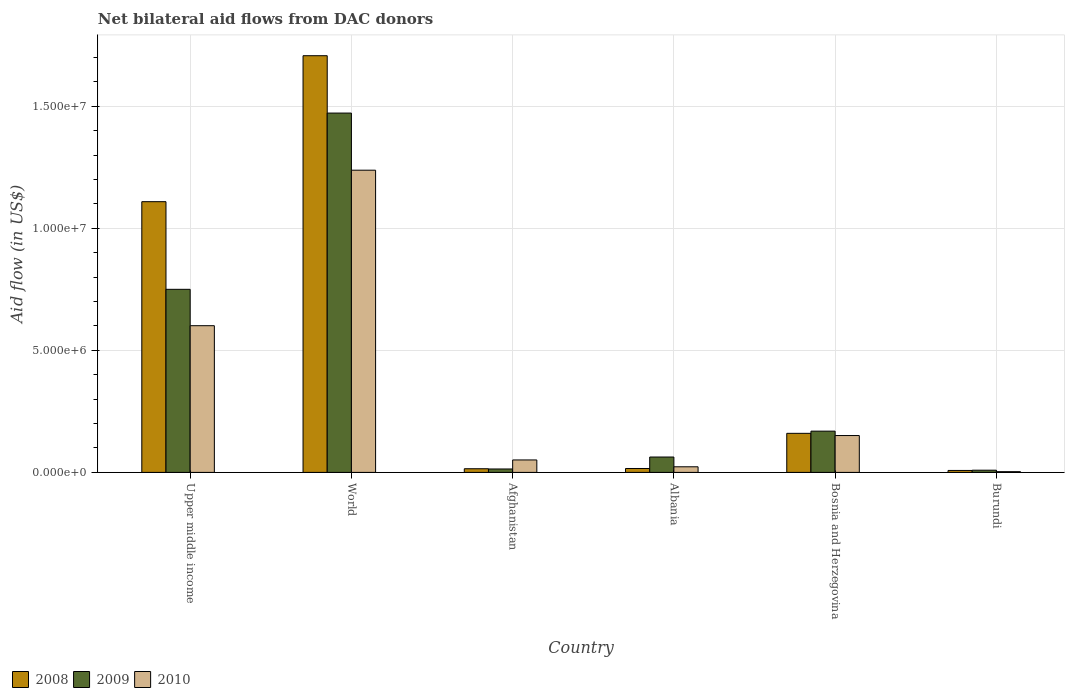How many different coloured bars are there?
Give a very brief answer. 3. Are the number of bars per tick equal to the number of legend labels?
Offer a very short reply. Yes. How many bars are there on the 4th tick from the left?
Ensure brevity in your answer.  3. How many bars are there on the 6th tick from the right?
Make the answer very short. 3. What is the label of the 5th group of bars from the left?
Your response must be concise. Bosnia and Herzegovina. What is the net bilateral aid flow in 2009 in Burundi?
Provide a succinct answer. 9.00e+04. Across all countries, what is the maximum net bilateral aid flow in 2008?
Offer a terse response. 1.71e+07. Across all countries, what is the minimum net bilateral aid flow in 2010?
Offer a terse response. 3.00e+04. In which country was the net bilateral aid flow in 2010 minimum?
Ensure brevity in your answer.  Burundi. What is the total net bilateral aid flow in 2010 in the graph?
Your response must be concise. 2.07e+07. What is the difference between the net bilateral aid flow in 2008 in Albania and that in World?
Keep it short and to the point. -1.69e+07. What is the difference between the net bilateral aid flow in 2009 in Albania and the net bilateral aid flow in 2010 in Upper middle income?
Give a very brief answer. -5.38e+06. What is the average net bilateral aid flow in 2008 per country?
Offer a terse response. 5.02e+06. What is the difference between the net bilateral aid flow of/in 2010 and net bilateral aid flow of/in 2009 in Albania?
Your response must be concise. -4.00e+05. In how many countries, is the net bilateral aid flow in 2010 greater than 8000000 US$?
Make the answer very short. 1. What is the ratio of the net bilateral aid flow in 2008 in Burundi to that in World?
Provide a short and direct response. 0. Is the net bilateral aid flow in 2008 in Afghanistan less than that in Burundi?
Your response must be concise. No. What is the difference between the highest and the second highest net bilateral aid flow in 2010?
Provide a short and direct response. 1.09e+07. What is the difference between the highest and the lowest net bilateral aid flow in 2010?
Offer a terse response. 1.24e+07. In how many countries, is the net bilateral aid flow in 2010 greater than the average net bilateral aid flow in 2010 taken over all countries?
Ensure brevity in your answer.  2. Is the sum of the net bilateral aid flow in 2009 in Afghanistan and Bosnia and Herzegovina greater than the maximum net bilateral aid flow in 2010 across all countries?
Offer a terse response. No. What does the 3rd bar from the right in Burundi represents?
Provide a short and direct response. 2008. Is it the case that in every country, the sum of the net bilateral aid flow in 2009 and net bilateral aid flow in 2008 is greater than the net bilateral aid flow in 2010?
Give a very brief answer. No. How many bars are there?
Your response must be concise. 18. Are all the bars in the graph horizontal?
Give a very brief answer. No. What is the difference between two consecutive major ticks on the Y-axis?
Offer a very short reply. 5.00e+06. Where does the legend appear in the graph?
Make the answer very short. Bottom left. What is the title of the graph?
Give a very brief answer. Net bilateral aid flows from DAC donors. What is the label or title of the X-axis?
Offer a very short reply. Country. What is the label or title of the Y-axis?
Your answer should be very brief. Aid flow (in US$). What is the Aid flow (in US$) of 2008 in Upper middle income?
Keep it short and to the point. 1.11e+07. What is the Aid flow (in US$) in 2009 in Upper middle income?
Your answer should be compact. 7.50e+06. What is the Aid flow (in US$) of 2010 in Upper middle income?
Your answer should be very brief. 6.01e+06. What is the Aid flow (in US$) of 2008 in World?
Your answer should be compact. 1.71e+07. What is the Aid flow (in US$) in 2009 in World?
Your answer should be compact. 1.47e+07. What is the Aid flow (in US$) of 2010 in World?
Your answer should be compact. 1.24e+07. What is the Aid flow (in US$) in 2010 in Afghanistan?
Keep it short and to the point. 5.10e+05. What is the Aid flow (in US$) in 2008 in Albania?
Provide a short and direct response. 1.60e+05. What is the Aid flow (in US$) of 2009 in Albania?
Keep it short and to the point. 6.30e+05. What is the Aid flow (in US$) of 2010 in Albania?
Offer a very short reply. 2.30e+05. What is the Aid flow (in US$) of 2008 in Bosnia and Herzegovina?
Keep it short and to the point. 1.60e+06. What is the Aid flow (in US$) of 2009 in Bosnia and Herzegovina?
Make the answer very short. 1.69e+06. What is the Aid flow (in US$) in 2010 in Bosnia and Herzegovina?
Offer a terse response. 1.51e+06. What is the Aid flow (in US$) in 2008 in Burundi?
Provide a succinct answer. 8.00e+04. Across all countries, what is the maximum Aid flow (in US$) in 2008?
Provide a short and direct response. 1.71e+07. Across all countries, what is the maximum Aid flow (in US$) in 2009?
Provide a short and direct response. 1.47e+07. Across all countries, what is the maximum Aid flow (in US$) of 2010?
Provide a short and direct response. 1.24e+07. Across all countries, what is the minimum Aid flow (in US$) of 2009?
Provide a succinct answer. 9.00e+04. Across all countries, what is the minimum Aid flow (in US$) of 2010?
Provide a short and direct response. 3.00e+04. What is the total Aid flow (in US$) of 2008 in the graph?
Ensure brevity in your answer.  3.02e+07. What is the total Aid flow (in US$) of 2009 in the graph?
Your answer should be very brief. 2.48e+07. What is the total Aid flow (in US$) in 2010 in the graph?
Provide a short and direct response. 2.07e+07. What is the difference between the Aid flow (in US$) in 2008 in Upper middle income and that in World?
Your answer should be compact. -5.98e+06. What is the difference between the Aid flow (in US$) in 2009 in Upper middle income and that in World?
Your answer should be very brief. -7.22e+06. What is the difference between the Aid flow (in US$) of 2010 in Upper middle income and that in World?
Offer a terse response. -6.37e+06. What is the difference between the Aid flow (in US$) of 2008 in Upper middle income and that in Afghanistan?
Offer a very short reply. 1.09e+07. What is the difference between the Aid flow (in US$) in 2009 in Upper middle income and that in Afghanistan?
Give a very brief answer. 7.36e+06. What is the difference between the Aid flow (in US$) of 2010 in Upper middle income and that in Afghanistan?
Provide a succinct answer. 5.50e+06. What is the difference between the Aid flow (in US$) of 2008 in Upper middle income and that in Albania?
Your response must be concise. 1.09e+07. What is the difference between the Aid flow (in US$) in 2009 in Upper middle income and that in Albania?
Make the answer very short. 6.87e+06. What is the difference between the Aid flow (in US$) of 2010 in Upper middle income and that in Albania?
Your answer should be compact. 5.78e+06. What is the difference between the Aid flow (in US$) of 2008 in Upper middle income and that in Bosnia and Herzegovina?
Ensure brevity in your answer.  9.49e+06. What is the difference between the Aid flow (in US$) in 2009 in Upper middle income and that in Bosnia and Herzegovina?
Offer a terse response. 5.81e+06. What is the difference between the Aid flow (in US$) in 2010 in Upper middle income and that in Bosnia and Herzegovina?
Offer a terse response. 4.50e+06. What is the difference between the Aid flow (in US$) in 2008 in Upper middle income and that in Burundi?
Offer a terse response. 1.10e+07. What is the difference between the Aid flow (in US$) in 2009 in Upper middle income and that in Burundi?
Make the answer very short. 7.41e+06. What is the difference between the Aid flow (in US$) in 2010 in Upper middle income and that in Burundi?
Provide a short and direct response. 5.98e+06. What is the difference between the Aid flow (in US$) in 2008 in World and that in Afghanistan?
Provide a succinct answer. 1.69e+07. What is the difference between the Aid flow (in US$) of 2009 in World and that in Afghanistan?
Ensure brevity in your answer.  1.46e+07. What is the difference between the Aid flow (in US$) in 2010 in World and that in Afghanistan?
Your response must be concise. 1.19e+07. What is the difference between the Aid flow (in US$) of 2008 in World and that in Albania?
Keep it short and to the point. 1.69e+07. What is the difference between the Aid flow (in US$) of 2009 in World and that in Albania?
Provide a succinct answer. 1.41e+07. What is the difference between the Aid flow (in US$) of 2010 in World and that in Albania?
Provide a short and direct response. 1.22e+07. What is the difference between the Aid flow (in US$) of 2008 in World and that in Bosnia and Herzegovina?
Offer a very short reply. 1.55e+07. What is the difference between the Aid flow (in US$) of 2009 in World and that in Bosnia and Herzegovina?
Make the answer very short. 1.30e+07. What is the difference between the Aid flow (in US$) in 2010 in World and that in Bosnia and Herzegovina?
Give a very brief answer. 1.09e+07. What is the difference between the Aid flow (in US$) in 2008 in World and that in Burundi?
Give a very brief answer. 1.70e+07. What is the difference between the Aid flow (in US$) of 2009 in World and that in Burundi?
Your answer should be very brief. 1.46e+07. What is the difference between the Aid flow (in US$) in 2010 in World and that in Burundi?
Give a very brief answer. 1.24e+07. What is the difference between the Aid flow (in US$) in 2009 in Afghanistan and that in Albania?
Your answer should be compact. -4.90e+05. What is the difference between the Aid flow (in US$) of 2008 in Afghanistan and that in Bosnia and Herzegovina?
Provide a succinct answer. -1.45e+06. What is the difference between the Aid flow (in US$) in 2009 in Afghanistan and that in Bosnia and Herzegovina?
Ensure brevity in your answer.  -1.55e+06. What is the difference between the Aid flow (in US$) in 2010 in Afghanistan and that in Bosnia and Herzegovina?
Make the answer very short. -1.00e+06. What is the difference between the Aid flow (in US$) in 2009 in Afghanistan and that in Burundi?
Offer a terse response. 5.00e+04. What is the difference between the Aid flow (in US$) in 2010 in Afghanistan and that in Burundi?
Your answer should be compact. 4.80e+05. What is the difference between the Aid flow (in US$) of 2008 in Albania and that in Bosnia and Herzegovina?
Your answer should be very brief. -1.44e+06. What is the difference between the Aid flow (in US$) of 2009 in Albania and that in Bosnia and Herzegovina?
Your answer should be compact. -1.06e+06. What is the difference between the Aid flow (in US$) in 2010 in Albania and that in Bosnia and Herzegovina?
Keep it short and to the point. -1.28e+06. What is the difference between the Aid flow (in US$) of 2008 in Albania and that in Burundi?
Offer a terse response. 8.00e+04. What is the difference between the Aid flow (in US$) of 2009 in Albania and that in Burundi?
Provide a short and direct response. 5.40e+05. What is the difference between the Aid flow (in US$) of 2008 in Bosnia and Herzegovina and that in Burundi?
Your answer should be very brief. 1.52e+06. What is the difference between the Aid flow (in US$) of 2009 in Bosnia and Herzegovina and that in Burundi?
Give a very brief answer. 1.60e+06. What is the difference between the Aid flow (in US$) of 2010 in Bosnia and Herzegovina and that in Burundi?
Your response must be concise. 1.48e+06. What is the difference between the Aid flow (in US$) of 2008 in Upper middle income and the Aid flow (in US$) of 2009 in World?
Your answer should be compact. -3.63e+06. What is the difference between the Aid flow (in US$) of 2008 in Upper middle income and the Aid flow (in US$) of 2010 in World?
Provide a short and direct response. -1.29e+06. What is the difference between the Aid flow (in US$) in 2009 in Upper middle income and the Aid flow (in US$) in 2010 in World?
Provide a succinct answer. -4.88e+06. What is the difference between the Aid flow (in US$) in 2008 in Upper middle income and the Aid flow (in US$) in 2009 in Afghanistan?
Keep it short and to the point. 1.10e+07. What is the difference between the Aid flow (in US$) of 2008 in Upper middle income and the Aid flow (in US$) of 2010 in Afghanistan?
Offer a very short reply. 1.06e+07. What is the difference between the Aid flow (in US$) in 2009 in Upper middle income and the Aid flow (in US$) in 2010 in Afghanistan?
Make the answer very short. 6.99e+06. What is the difference between the Aid flow (in US$) in 2008 in Upper middle income and the Aid flow (in US$) in 2009 in Albania?
Your answer should be compact. 1.05e+07. What is the difference between the Aid flow (in US$) in 2008 in Upper middle income and the Aid flow (in US$) in 2010 in Albania?
Keep it short and to the point. 1.09e+07. What is the difference between the Aid flow (in US$) in 2009 in Upper middle income and the Aid flow (in US$) in 2010 in Albania?
Ensure brevity in your answer.  7.27e+06. What is the difference between the Aid flow (in US$) of 2008 in Upper middle income and the Aid flow (in US$) of 2009 in Bosnia and Herzegovina?
Your response must be concise. 9.40e+06. What is the difference between the Aid flow (in US$) in 2008 in Upper middle income and the Aid flow (in US$) in 2010 in Bosnia and Herzegovina?
Offer a terse response. 9.58e+06. What is the difference between the Aid flow (in US$) of 2009 in Upper middle income and the Aid flow (in US$) of 2010 in Bosnia and Herzegovina?
Provide a short and direct response. 5.99e+06. What is the difference between the Aid flow (in US$) in 2008 in Upper middle income and the Aid flow (in US$) in 2009 in Burundi?
Offer a very short reply. 1.10e+07. What is the difference between the Aid flow (in US$) of 2008 in Upper middle income and the Aid flow (in US$) of 2010 in Burundi?
Your answer should be very brief. 1.11e+07. What is the difference between the Aid flow (in US$) in 2009 in Upper middle income and the Aid flow (in US$) in 2010 in Burundi?
Provide a succinct answer. 7.47e+06. What is the difference between the Aid flow (in US$) in 2008 in World and the Aid flow (in US$) in 2009 in Afghanistan?
Provide a short and direct response. 1.69e+07. What is the difference between the Aid flow (in US$) of 2008 in World and the Aid flow (in US$) of 2010 in Afghanistan?
Ensure brevity in your answer.  1.66e+07. What is the difference between the Aid flow (in US$) of 2009 in World and the Aid flow (in US$) of 2010 in Afghanistan?
Offer a terse response. 1.42e+07. What is the difference between the Aid flow (in US$) of 2008 in World and the Aid flow (in US$) of 2009 in Albania?
Give a very brief answer. 1.64e+07. What is the difference between the Aid flow (in US$) of 2008 in World and the Aid flow (in US$) of 2010 in Albania?
Ensure brevity in your answer.  1.68e+07. What is the difference between the Aid flow (in US$) of 2009 in World and the Aid flow (in US$) of 2010 in Albania?
Your answer should be very brief. 1.45e+07. What is the difference between the Aid flow (in US$) of 2008 in World and the Aid flow (in US$) of 2009 in Bosnia and Herzegovina?
Your response must be concise. 1.54e+07. What is the difference between the Aid flow (in US$) in 2008 in World and the Aid flow (in US$) in 2010 in Bosnia and Herzegovina?
Make the answer very short. 1.56e+07. What is the difference between the Aid flow (in US$) in 2009 in World and the Aid flow (in US$) in 2010 in Bosnia and Herzegovina?
Offer a terse response. 1.32e+07. What is the difference between the Aid flow (in US$) in 2008 in World and the Aid flow (in US$) in 2009 in Burundi?
Keep it short and to the point. 1.70e+07. What is the difference between the Aid flow (in US$) of 2008 in World and the Aid flow (in US$) of 2010 in Burundi?
Offer a very short reply. 1.70e+07. What is the difference between the Aid flow (in US$) of 2009 in World and the Aid flow (in US$) of 2010 in Burundi?
Provide a succinct answer. 1.47e+07. What is the difference between the Aid flow (in US$) of 2008 in Afghanistan and the Aid flow (in US$) of 2009 in Albania?
Provide a short and direct response. -4.80e+05. What is the difference between the Aid flow (in US$) of 2009 in Afghanistan and the Aid flow (in US$) of 2010 in Albania?
Offer a terse response. -9.00e+04. What is the difference between the Aid flow (in US$) in 2008 in Afghanistan and the Aid flow (in US$) in 2009 in Bosnia and Herzegovina?
Offer a terse response. -1.54e+06. What is the difference between the Aid flow (in US$) in 2008 in Afghanistan and the Aid flow (in US$) in 2010 in Bosnia and Herzegovina?
Provide a succinct answer. -1.36e+06. What is the difference between the Aid flow (in US$) of 2009 in Afghanistan and the Aid flow (in US$) of 2010 in Bosnia and Herzegovina?
Give a very brief answer. -1.37e+06. What is the difference between the Aid flow (in US$) of 2009 in Afghanistan and the Aid flow (in US$) of 2010 in Burundi?
Keep it short and to the point. 1.10e+05. What is the difference between the Aid flow (in US$) in 2008 in Albania and the Aid flow (in US$) in 2009 in Bosnia and Herzegovina?
Offer a terse response. -1.53e+06. What is the difference between the Aid flow (in US$) in 2008 in Albania and the Aid flow (in US$) in 2010 in Bosnia and Herzegovina?
Provide a succinct answer. -1.35e+06. What is the difference between the Aid flow (in US$) of 2009 in Albania and the Aid flow (in US$) of 2010 in Bosnia and Herzegovina?
Make the answer very short. -8.80e+05. What is the difference between the Aid flow (in US$) in 2008 in Albania and the Aid flow (in US$) in 2010 in Burundi?
Make the answer very short. 1.30e+05. What is the difference between the Aid flow (in US$) of 2009 in Albania and the Aid flow (in US$) of 2010 in Burundi?
Ensure brevity in your answer.  6.00e+05. What is the difference between the Aid flow (in US$) in 2008 in Bosnia and Herzegovina and the Aid flow (in US$) in 2009 in Burundi?
Make the answer very short. 1.51e+06. What is the difference between the Aid flow (in US$) of 2008 in Bosnia and Herzegovina and the Aid flow (in US$) of 2010 in Burundi?
Your response must be concise. 1.57e+06. What is the difference between the Aid flow (in US$) of 2009 in Bosnia and Herzegovina and the Aid flow (in US$) of 2010 in Burundi?
Offer a terse response. 1.66e+06. What is the average Aid flow (in US$) in 2008 per country?
Your answer should be very brief. 5.02e+06. What is the average Aid flow (in US$) of 2009 per country?
Offer a terse response. 4.13e+06. What is the average Aid flow (in US$) of 2010 per country?
Ensure brevity in your answer.  3.44e+06. What is the difference between the Aid flow (in US$) in 2008 and Aid flow (in US$) in 2009 in Upper middle income?
Provide a short and direct response. 3.59e+06. What is the difference between the Aid flow (in US$) in 2008 and Aid flow (in US$) in 2010 in Upper middle income?
Your answer should be compact. 5.08e+06. What is the difference between the Aid flow (in US$) of 2009 and Aid flow (in US$) of 2010 in Upper middle income?
Offer a terse response. 1.49e+06. What is the difference between the Aid flow (in US$) in 2008 and Aid flow (in US$) in 2009 in World?
Provide a succinct answer. 2.35e+06. What is the difference between the Aid flow (in US$) in 2008 and Aid flow (in US$) in 2010 in World?
Provide a succinct answer. 4.69e+06. What is the difference between the Aid flow (in US$) of 2009 and Aid flow (in US$) of 2010 in World?
Offer a terse response. 2.34e+06. What is the difference between the Aid flow (in US$) in 2008 and Aid flow (in US$) in 2010 in Afghanistan?
Ensure brevity in your answer.  -3.60e+05. What is the difference between the Aid flow (in US$) in 2009 and Aid flow (in US$) in 2010 in Afghanistan?
Provide a succinct answer. -3.70e+05. What is the difference between the Aid flow (in US$) of 2008 and Aid flow (in US$) of 2009 in Albania?
Ensure brevity in your answer.  -4.70e+05. What is the difference between the Aid flow (in US$) of 2008 and Aid flow (in US$) of 2009 in Bosnia and Herzegovina?
Give a very brief answer. -9.00e+04. What is the difference between the Aid flow (in US$) of 2009 and Aid flow (in US$) of 2010 in Bosnia and Herzegovina?
Your answer should be very brief. 1.80e+05. What is the difference between the Aid flow (in US$) in 2009 and Aid flow (in US$) in 2010 in Burundi?
Your response must be concise. 6.00e+04. What is the ratio of the Aid flow (in US$) in 2008 in Upper middle income to that in World?
Offer a terse response. 0.65. What is the ratio of the Aid flow (in US$) in 2009 in Upper middle income to that in World?
Your response must be concise. 0.51. What is the ratio of the Aid flow (in US$) in 2010 in Upper middle income to that in World?
Make the answer very short. 0.49. What is the ratio of the Aid flow (in US$) of 2008 in Upper middle income to that in Afghanistan?
Keep it short and to the point. 73.93. What is the ratio of the Aid flow (in US$) in 2009 in Upper middle income to that in Afghanistan?
Your answer should be very brief. 53.57. What is the ratio of the Aid flow (in US$) of 2010 in Upper middle income to that in Afghanistan?
Your response must be concise. 11.78. What is the ratio of the Aid flow (in US$) in 2008 in Upper middle income to that in Albania?
Your answer should be very brief. 69.31. What is the ratio of the Aid flow (in US$) in 2009 in Upper middle income to that in Albania?
Offer a very short reply. 11.9. What is the ratio of the Aid flow (in US$) of 2010 in Upper middle income to that in Albania?
Your answer should be compact. 26.13. What is the ratio of the Aid flow (in US$) of 2008 in Upper middle income to that in Bosnia and Herzegovina?
Offer a terse response. 6.93. What is the ratio of the Aid flow (in US$) of 2009 in Upper middle income to that in Bosnia and Herzegovina?
Your answer should be compact. 4.44. What is the ratio of the Aid flow (in US$) of 2010 in Upper middle income to that in Bosnia and Herzegovina?
Give a very brief answer. 3.98. What is the ratio of the Aid flow (in US$) of 2008 in Upper middle income to that in Burundi?
Your answer should be compact. 138.62. What is the ratio of the Aid flow (in US$) of 2009 in Upper middle income to that in Burundi?
Ensure brevity in your answer.  83.33. What is the ratio of the Aid flow (in US$) of 2010 in Upper middle income to that in Burundi?
Keep it short and to the point. 200.33. What is the ratio of the Aid flow (in US$) in 2008 in World to that in Afghanistan?
Provide a succinct answer. 113.8. What is the ratio of the Aid flow (in US$) in 2009 in World to that in Afghanistan?
Your answer should be compact. 105.14. What is the ratio of the Aid flow (in US$) of 2010 in World to that in Afghanistan?
Your answer should be compact. 24.27. What is the ratio of the Aid flow (in US$) in 2008 in World to that in Albania?
Provide a succinct answer. 106.69. What is the ratio of the Aid flow (in US$) of 2009 in World to that in Albania?
Ensure brevity in your answer.  23.37. What is the ratio of the Aid flow (in US$) of 2010 in World to that in Albania?
Your answer should be very brief. 53.83. What is the ratio of the Aid flow (in US$) of 2008 in World to that in Bosnia and Herzegovina?
Provide a short and direct response. 10.67. What is the ratio of the Aid flow (in US$) in 2009 in World to that in Bosnia and Herzegovina?
Keep it short and to the point. 8.71. What is the ratio of the Aid flow (in US$) in 2010 in World to that in Bosnia and Herzegovina?
Make the answer very short. 8.2. What is the ratio of the Aid flow (in US$) in 2008 in World to that in Burundi?
Offer a terse response. 213.38. What is the ratio of the Aid flow (in US$) in 2009 in World to that in Burundi?
Provide a succinct answer. 163.56. What is the ratio of the Aid flow (in US$) in 2010 in World to that in Burundi?
Make the answer very short. 412.67. What is the ratio of the Aid flow (in US$) in 2009 in Afghanistan to that in Albania?
Your answer should be compact. 0.22. What is the ratio of the Aid flow (in US$) in 2010 in Afghanistan to that in Albania?
Offer a terse response. 2.22. What is the ratio of the Aid flow (in US$) in 2008 in Afghanistan to that in Bosnia and Herzegovina?
Make the answer very short. 0.09. What is the ratio of the Aid flow (in US$) of 2009 in Afghanistan to that in Bosnia and Herzegovina?
Your answer should be very brief. 0.08. What is the ratio of the Aid flow (in US$) of 2010 in Afghanistan to that in Bosnia and Herzegovina?
Your response must be concise. 0.34. What is the ratio of the Aid flow (in US$) in 2008 in Afghanistan to that in Burundi?
Provide a succinct answer. 1.88. What is the ratio of the Aid flow (in US$) in 2009 in Afghanistan to that in Burundi?
Provide a short and direct response. 1.56. What is the ratio of the Aid flow (in US$) of 2009 in Albania to that in Bosnia and Herzegovina?
Offer a terse response. 0.37. What is the ratio of the Aid flow (in US$) in 2010 in Albania to that in Bosnia and Herzegovina?
Make the answer very short. 0.15. What is the ratio of the Aid flow (in US$) in 2008 in Albania to that in Burundi?
Your response must be concise. 2. What is the ratio of the Aid flow (in US$) in 2010 in Albania to that in Burundi?
Make the answer very short. 7.67. What is the ratio of the Aid flow (in US$) in 2008 in Bosnia and Herzegovina to that in Burundi?
Keep it short and to the point. 20. What is the ratio of the Aid flow (in US$) of 2009 in Bosnia and Herzegovina to that in Burundi?
Offer a very short reply. 18.78. What is the ratio of the Aid flow (in US$) in 2010 in Bosnia and Herzegovina to that in Burundi?
Make the answer very short. 50.33. What is the difference between the highest and the second highest Aid flow (in US$) of 2008?
Offer a very short reply. 5.98e+06. What is the difference between the highest and the second highest Aid flow (in US$) of 2009?
Your answer should be very brief. 7.22e+06. What is the difference between the highest and the second highest Aid flow (in US$) of 2010?
Give a very brief answer. 6.37e+06. What is the difference between the highest and the lowest Aid flow (in US$) in 2008?
Provide a succinct answer. 1.70e+07. What is the difference between the highest and the lowest Aid flow (in US$) of 2009?
Offer a very short reply. 1.46e+07. What is the difference between the highest and the lowest Aid flow (in US$) of 2010?
Your answer should be very brief. 1.24e+07. 